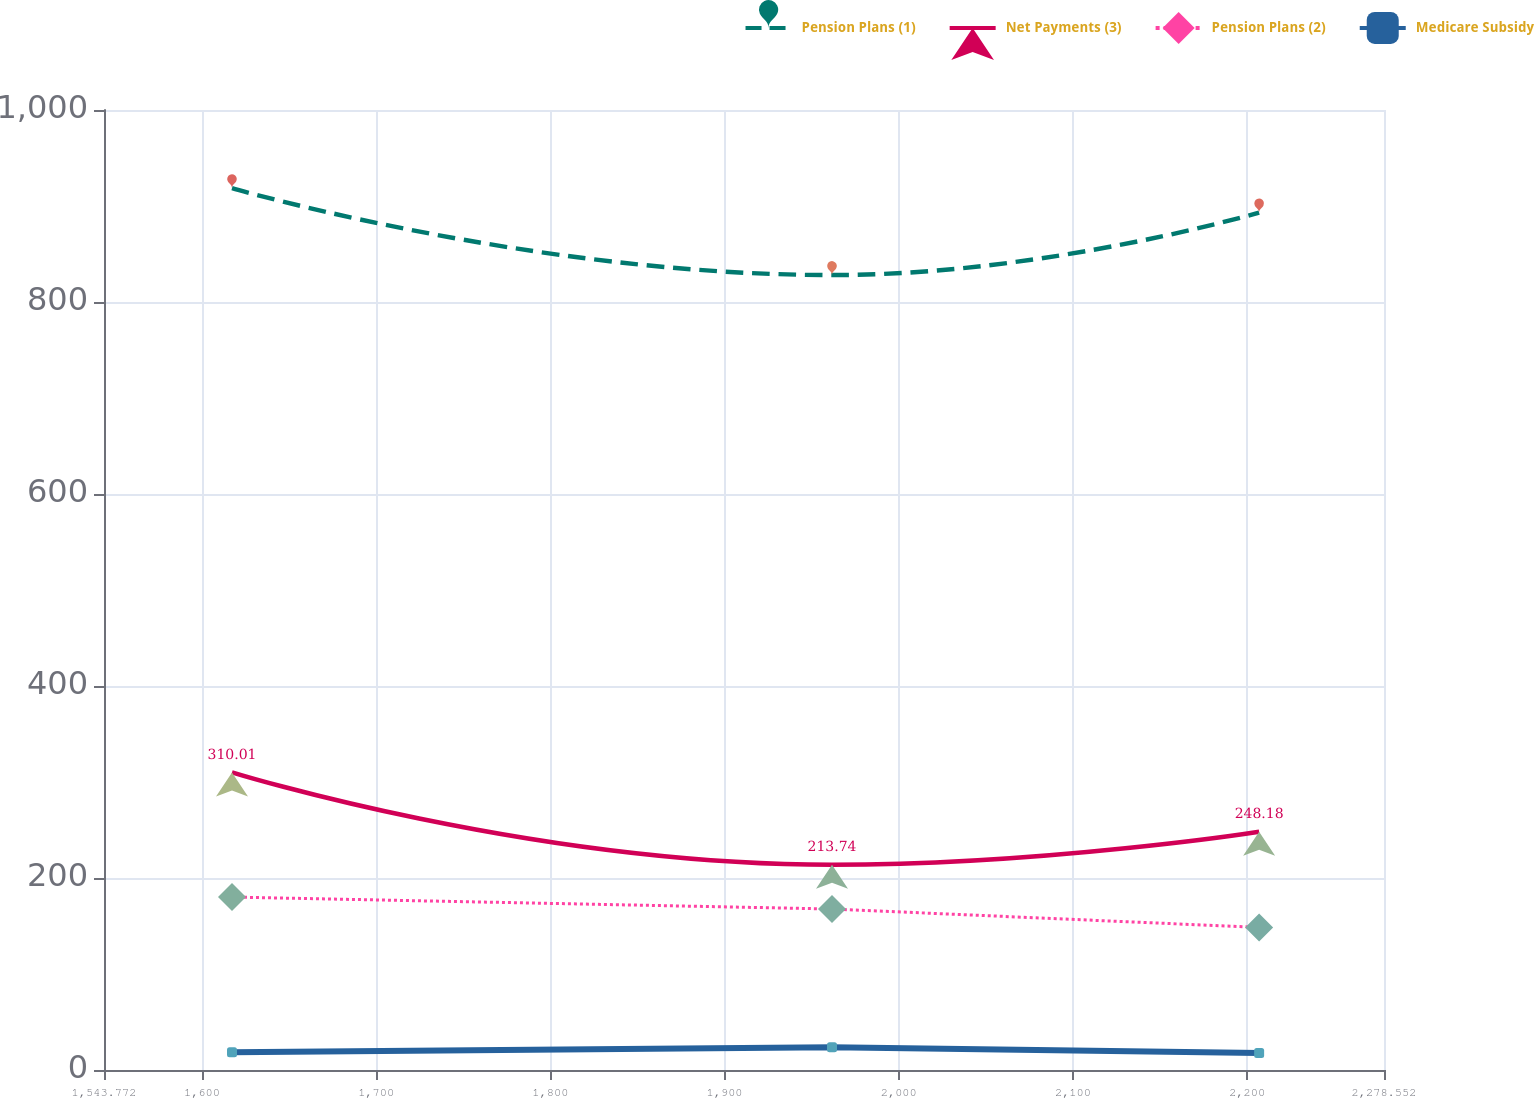<chart> <loc_0><loc_0><loc_500><loc_500><line_chart><ecel><fcel>Pension Plans (1)<fcel>Net Payments (3)<fcel>Pension Plans (2)<fcel>Medicare Subsidy<nl><fcel>1617.25<fcel>918.6<fcel>310.01<fcel>180.15<fcel>18.56<nl><fcel>1961.68<fcel>828.06<fcel>213.74<fcel>167.71<fcel>23.68<nl><fcel>2206.87<fcel>893.19<fcel>248.18<fcel>148.5<fcel>17.63<nl><fcel>2279.45<fcel>1009.73<fcel>232.34<fcel>135.54<fcel>21.4<nl><fcel>2352.03<fcel>755.64<fcel>319.88<fcel>140.39<fcel>22.38<nl></chart> 